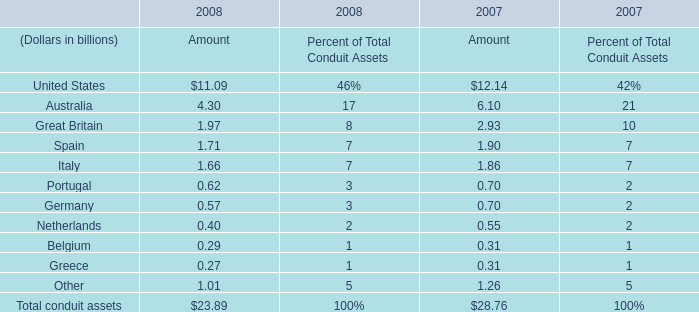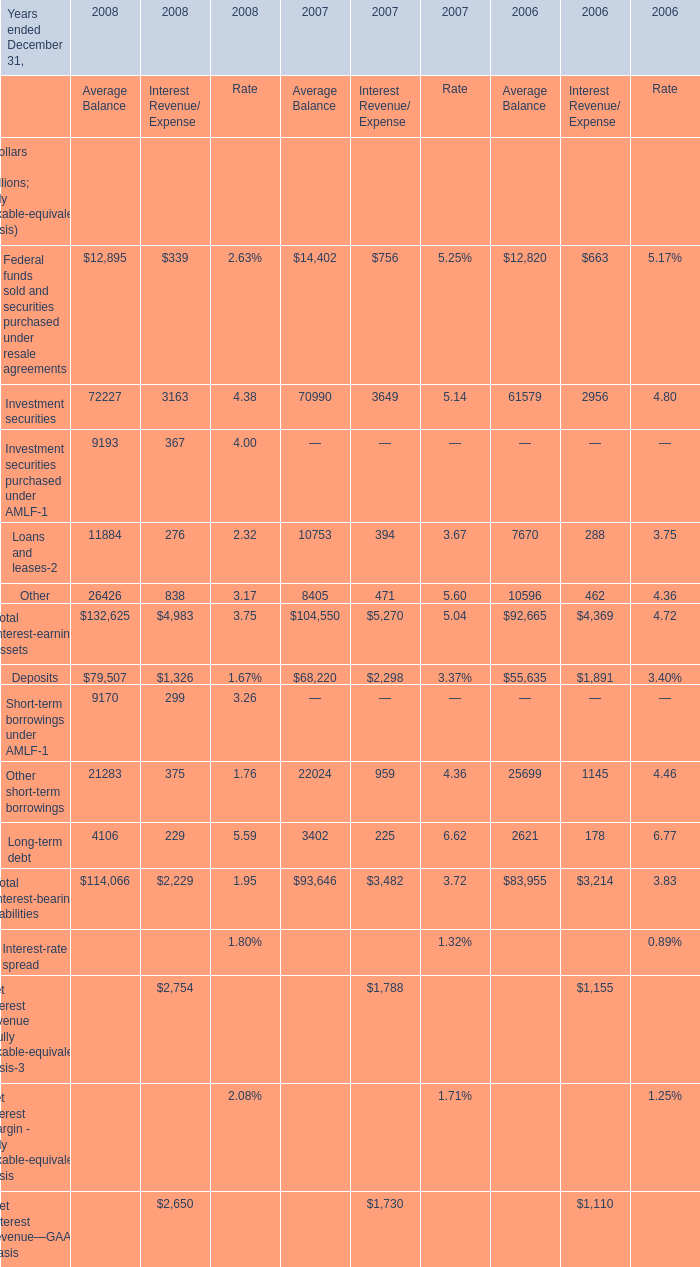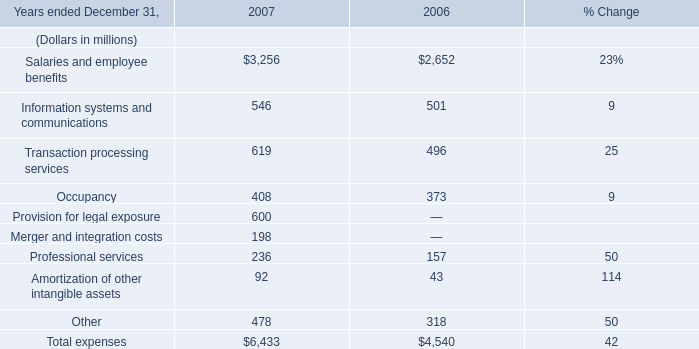In what year is the Amount of Total conduit assets greater than 28 billion? 
Answer: 2007. 